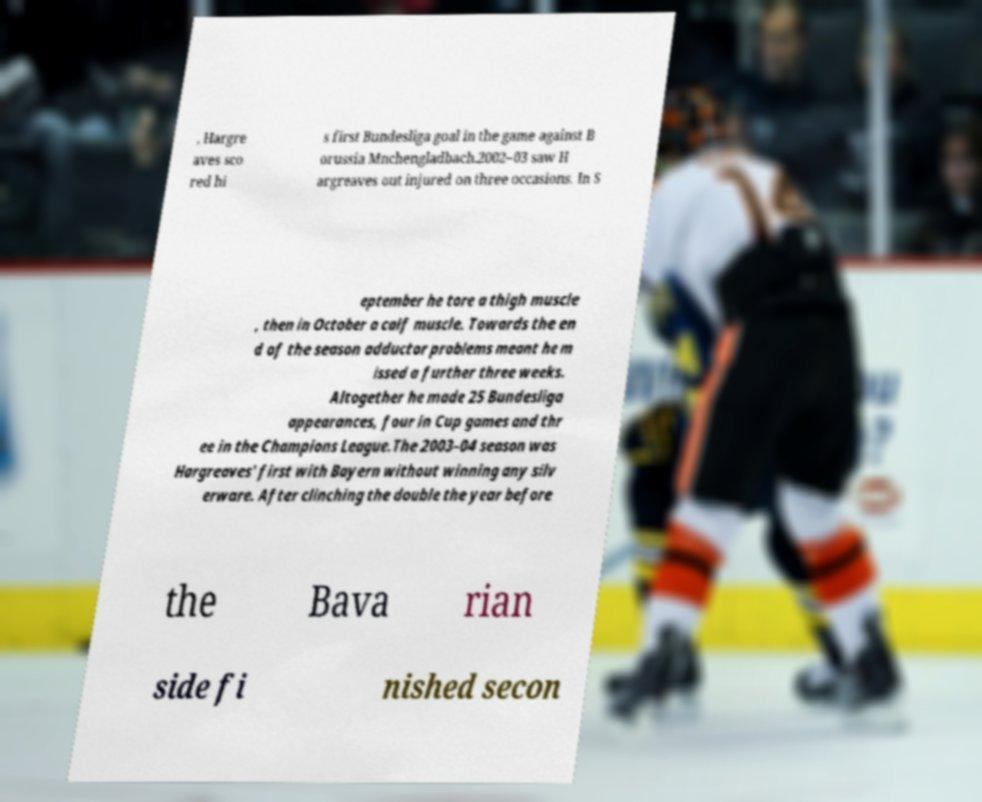Could you assist in decoding the text presented in this image and type it out clearly? , Hargre aves sco red hi s first Bundesliga goal in the game against B orussia Mnchengladbach.2002–03 saw H argreaves out injured on three occasions. In S eptember he tore a thigh muscle , then in October a calf muscle. Towards the en d of the season adductor problems meant he m issed a further three weeks. Altogether he made 25 Bundesliga appearances, four in Cup games and thr ee in the Champions League.The 2003–04 season was Hargreaves' first with Bayern without winning any silv erware. After clinching the double the year before the Bava rian side fi nished secon 